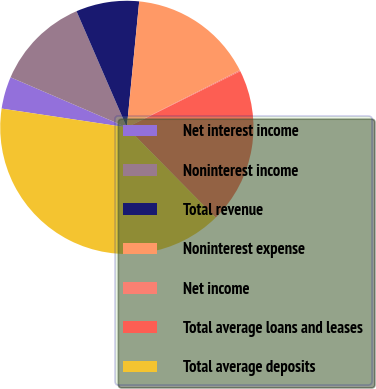Convert chart. <chart><loc_0><loc_0><loc_500><loc_500><pie_chart><fcel>Net interest income<fcel>Noninterest income<fcel>Total revenue<fcel>Noninterest expense<fcel>Net income<fcel>Total average loans and leases<fcel>Total average deposits<nl><fcel>4.1%<fcel>12.02%<fcel>8.06%<fcel>15.98%<fcel>0.14%<fcel>19.94%<fcel>39.75%<nl></chart> 